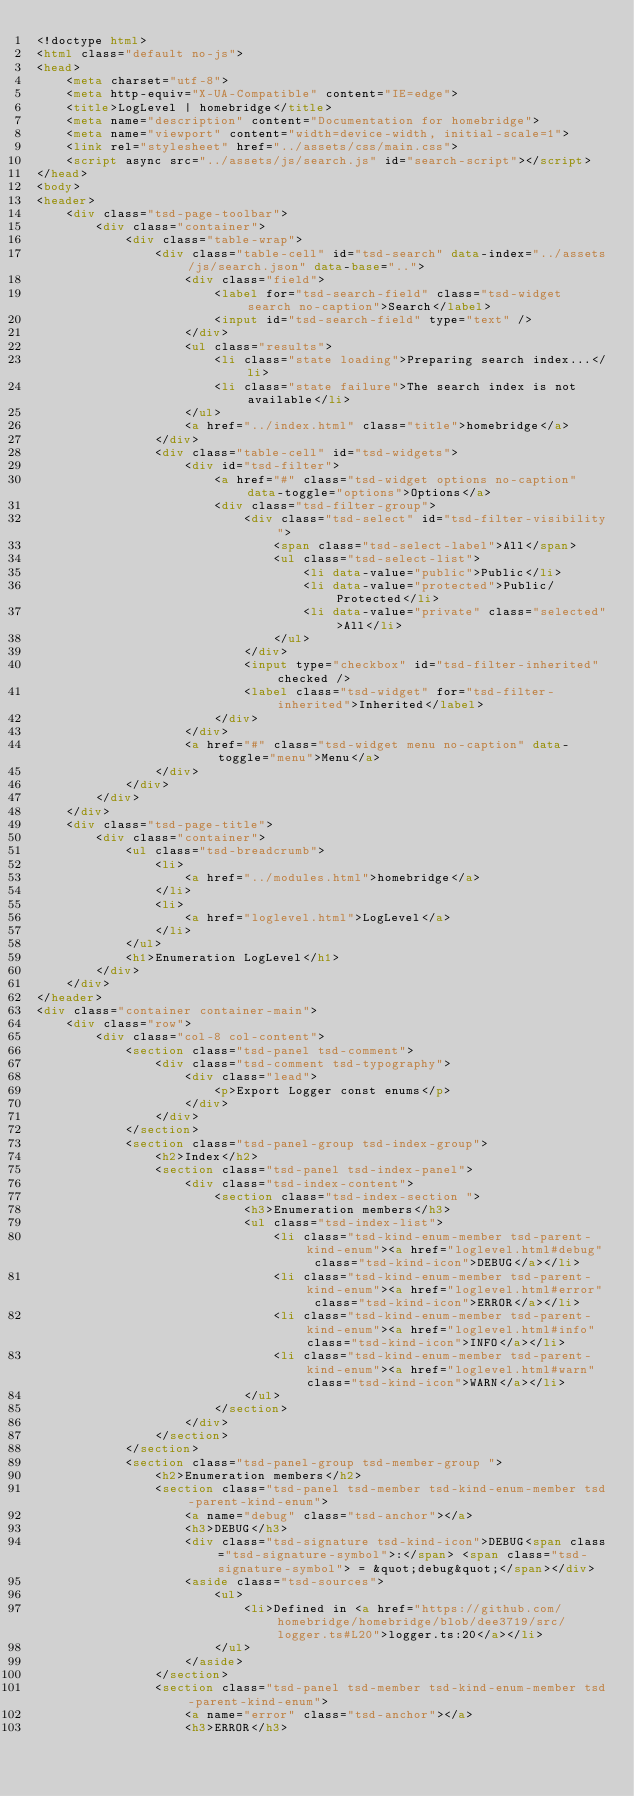<code> <loc_0><loc_0><loc_500><loc_500><_HTML_><!doctype html>
<html class="default no-js">
<head>
	<meta charset="utf-8">
	<meta http-equiv="X-UA-Compatible" content="IE=edge">
	<title>LogLevel | homebridge</title>
	<meta name="description" content="Documentation for homebridge">
	<meta name="viewport" content="width=device-width, initial-scale=1">
	<link rel="stylesheet" href="../assets/css/main.css">
	<script async src="../assets/js/search.js" id="search-script"></script>
</head>
<body>
<header>
	<div class="tsd-page-toolbar">
		<div class="container">
			<div class="table-wrap">
				<div class="table-cell" id="tsd-search" data-index="../assets/js/search.json" data-base="..">
					<div class="field">
						<label for="tsd-search-field" class="tsd-widget search no-caption">Search</label>
						<input id="tsd-search-field" type="text" />
					</div>
					<ul class="results">
						<li class="state loading">Preparing search index...</li>
						<li class="state failure">The search index is not available</li>
					</ul>
					<a href="../index.html" class="title">homebridge</a>
				</div>
				<div class="table-cell" id="tsd-widgets">
					<div id="tsd-filter">
						<a href="#" class="tsd-widget options no-caption" data-toggle="options">Options</a>
						<div class="tsd-filter-group">
							<div class="tsd-select" id="tsd-filter-visibility">
								<span class="tsd-select-label">All</span>
								<ul class="tsd-select-list">
									<li data-value="public">Public</li>
									<li data-value="protected">Public/Protected</li>
									<li data-value="private" class="selected">All</li>
								</ul>
							</div>
							<input type="checkbox" id="tsd-filter-inherited" checked />
							<label class="tsd-widget" for="tsd-filter-inherited">Inherited</label>
						</div>
					</div>
					<a href="#" class="tsd-widget menu no-caption" data-toggle="menu">Menu</a>
				</div>
			</div>
		</div>
	</div>
	<div class="tsd-page-title">
		<div class="container">
			<ul class="tsd-breadcrumb">
				<li>
					<a href="../modules.html">homebridge</a>
				</li>
				<li>
					<a href="loglevel.html">LogLevel</a>
				</li>
			</ul>
			<h1>Enumeration LogLevel</h1>
		</div>
	</div>
</header>
<div class="container container-main">
	<div class="row">
		<div class="col-8 col-content">
			<section class="tsd-panel tsd-comment">
				<div class="tsd-comment tsd-typography">
					<div class="lead">
						<p>Export Logger const enums</p>
					</div>
				</div>
			</section>
			<section class="tsd-panel-group tsd-index-group">
				<h2>Index</h2>
				<section class="tsd-panel tsd-index-panel">
					<div class="tsd-index-content">
						<section class="tsd-index-section ">
							<h3>Enumeration members</h3>
							<ul class="tsd-index-list">
								<li class="tsd-kind-enum-member tsd-parent-kind-enum"><a href="loglevel.html#debug" class="tsd-kind-icon">DEBUG</a></li>
								<li class="tsd-kind-enum-member tsd-parent-kind-enum"><a href="loglevel.html#error" class="tsd-kind-icon">ERROR</a></li>
								<li class="tsd-kind-enum-member tsd-parent-kind-enum"><a href="loglevel.html#info" class="tsd-kind-icon">INFO</a></li>
								<li class="tsd-kind-enum-member tsd-parent-kind-enum"><a href="loglevel.html#warn" class="tsd-kind-icon">WARN</a></li>
							</ul>
						</section>
					</div>
				</section>
			</section>
			<section class="tsd-panel-group tsd-member-group ">
				<h2>Enumeration members</h2>
				<section class="tsd-panel tsd-member tsd-kind-enum-member tsd-parent-kind-enum">
					<a name="debug" class="tsd-anchor"></a>
					<h3>DEBUG</h3>
					<div class="tsd-signature tsd-kind-icon">DEBUG<span class="tsd-signature-symbol">:</span> <span class="tsd-signature-symbol"> = &quot;debug&quot;</span></div>
					<aside class="tsd-sources">
						<ul>
							<li>Defined in <a href="https://github.com/homebridge/homebridge/blob/dee3719/src/logger.ts#L20">logger.ts:20</a></li>
						</ul>
					</aside>
				</section>
				<section class="tsd-panel tsd-member tsd-kind-enum-member tsd-parent-kind-enum">
					<a name="error" class="tsd-anchor"></a>
					<h3>ERROR</h3></code> 